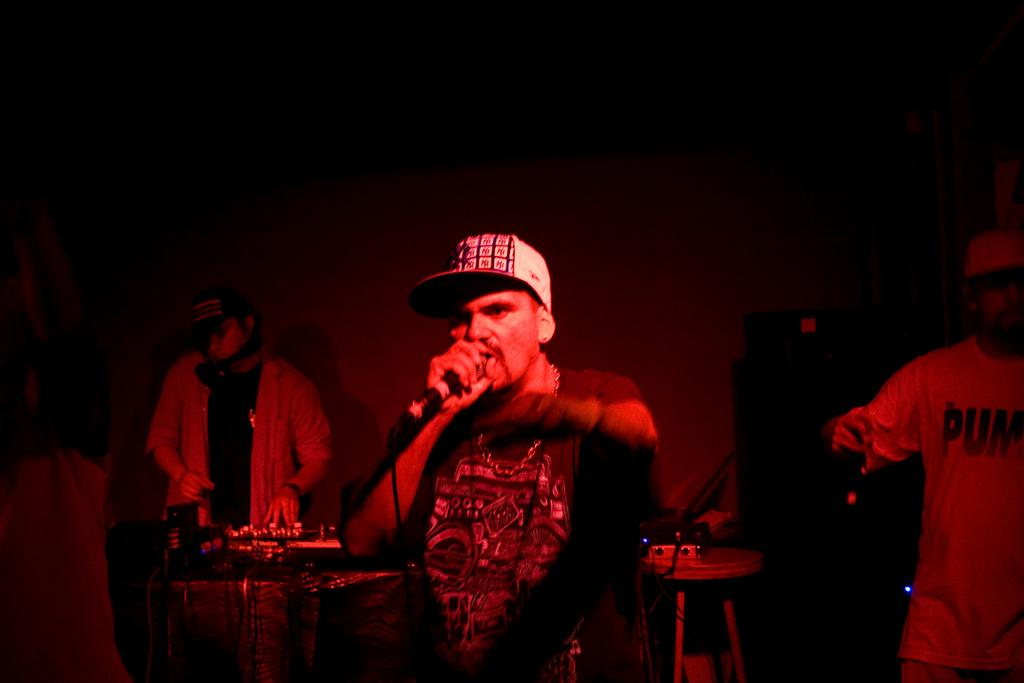Who is the main subject in the image? There is a man in the middle of the image. What is the man doing in the image? The man is singing on a microphone. Are there any other people in the image? Yes, there are other men in the background of the image. What are the men in the background doing? The men in the background are playing musical instruments. How many horses can be seen in the image? There are no horses present in the image. Is there a picture of a calculator on the wall in the image? There is no mention of a wall or a calculator in the provided facts, so we cannot determine if there is a picture of a calculator in the image. 